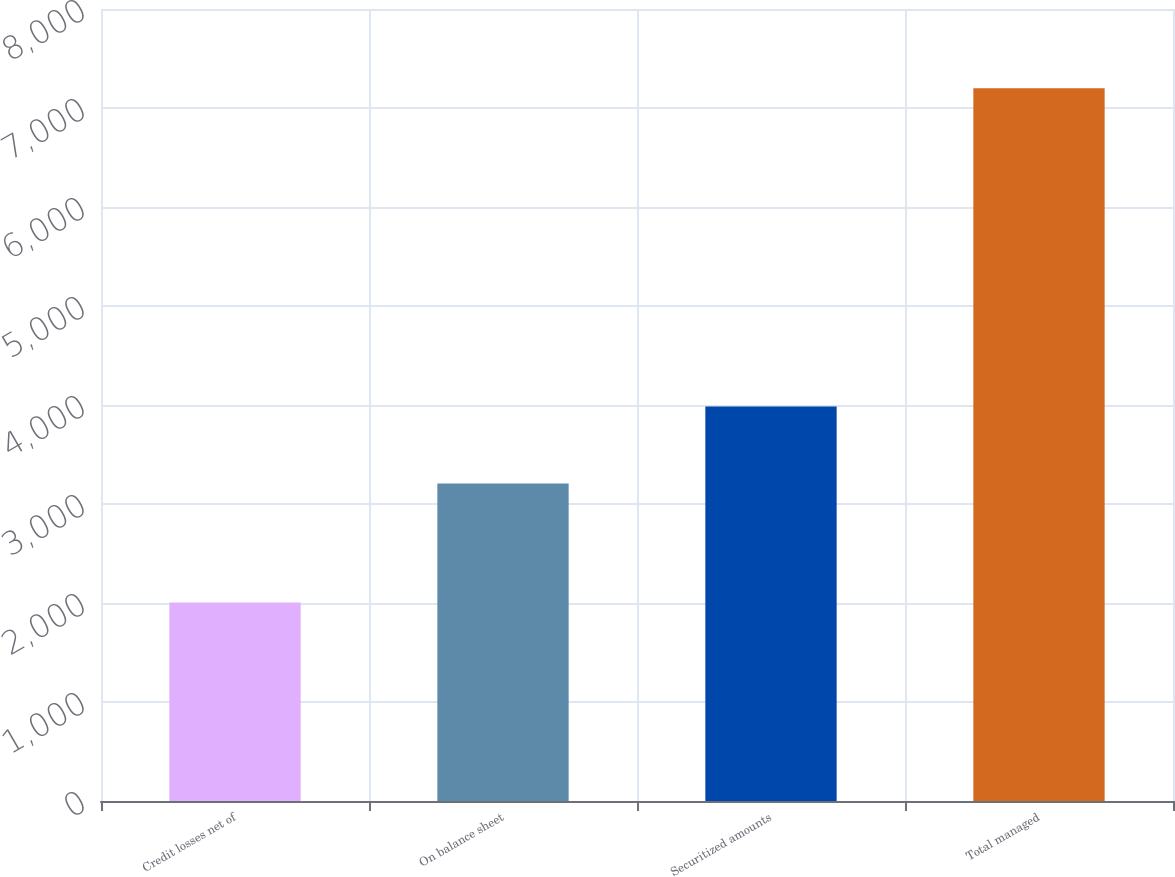Convert chart. <chart><loc_0><loc_0><loc_500><loc_500><bar_chart><fcel>Credit losses net of<fcel>On balance sheet<fcel>Securitized amounts<fcel>Total managed<nl><fcel>2006<fcel>3208<fcel>3986<fcel>7199<nl></chart> 